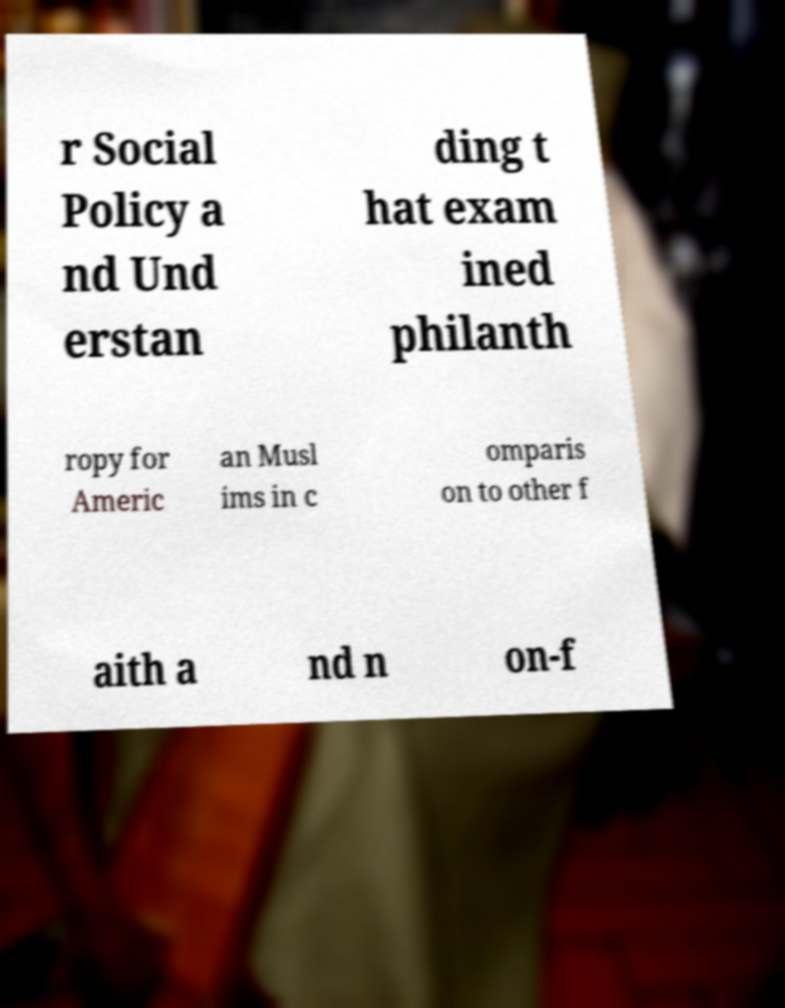There's text embedded in this image that I need extracted. Can you transcribe it verbatim? r Social Policy a nd Und erstan ding t hat exam ined philanth ropy for Americ an Musl ims in c omparis on to other f aith a nd n on-f 